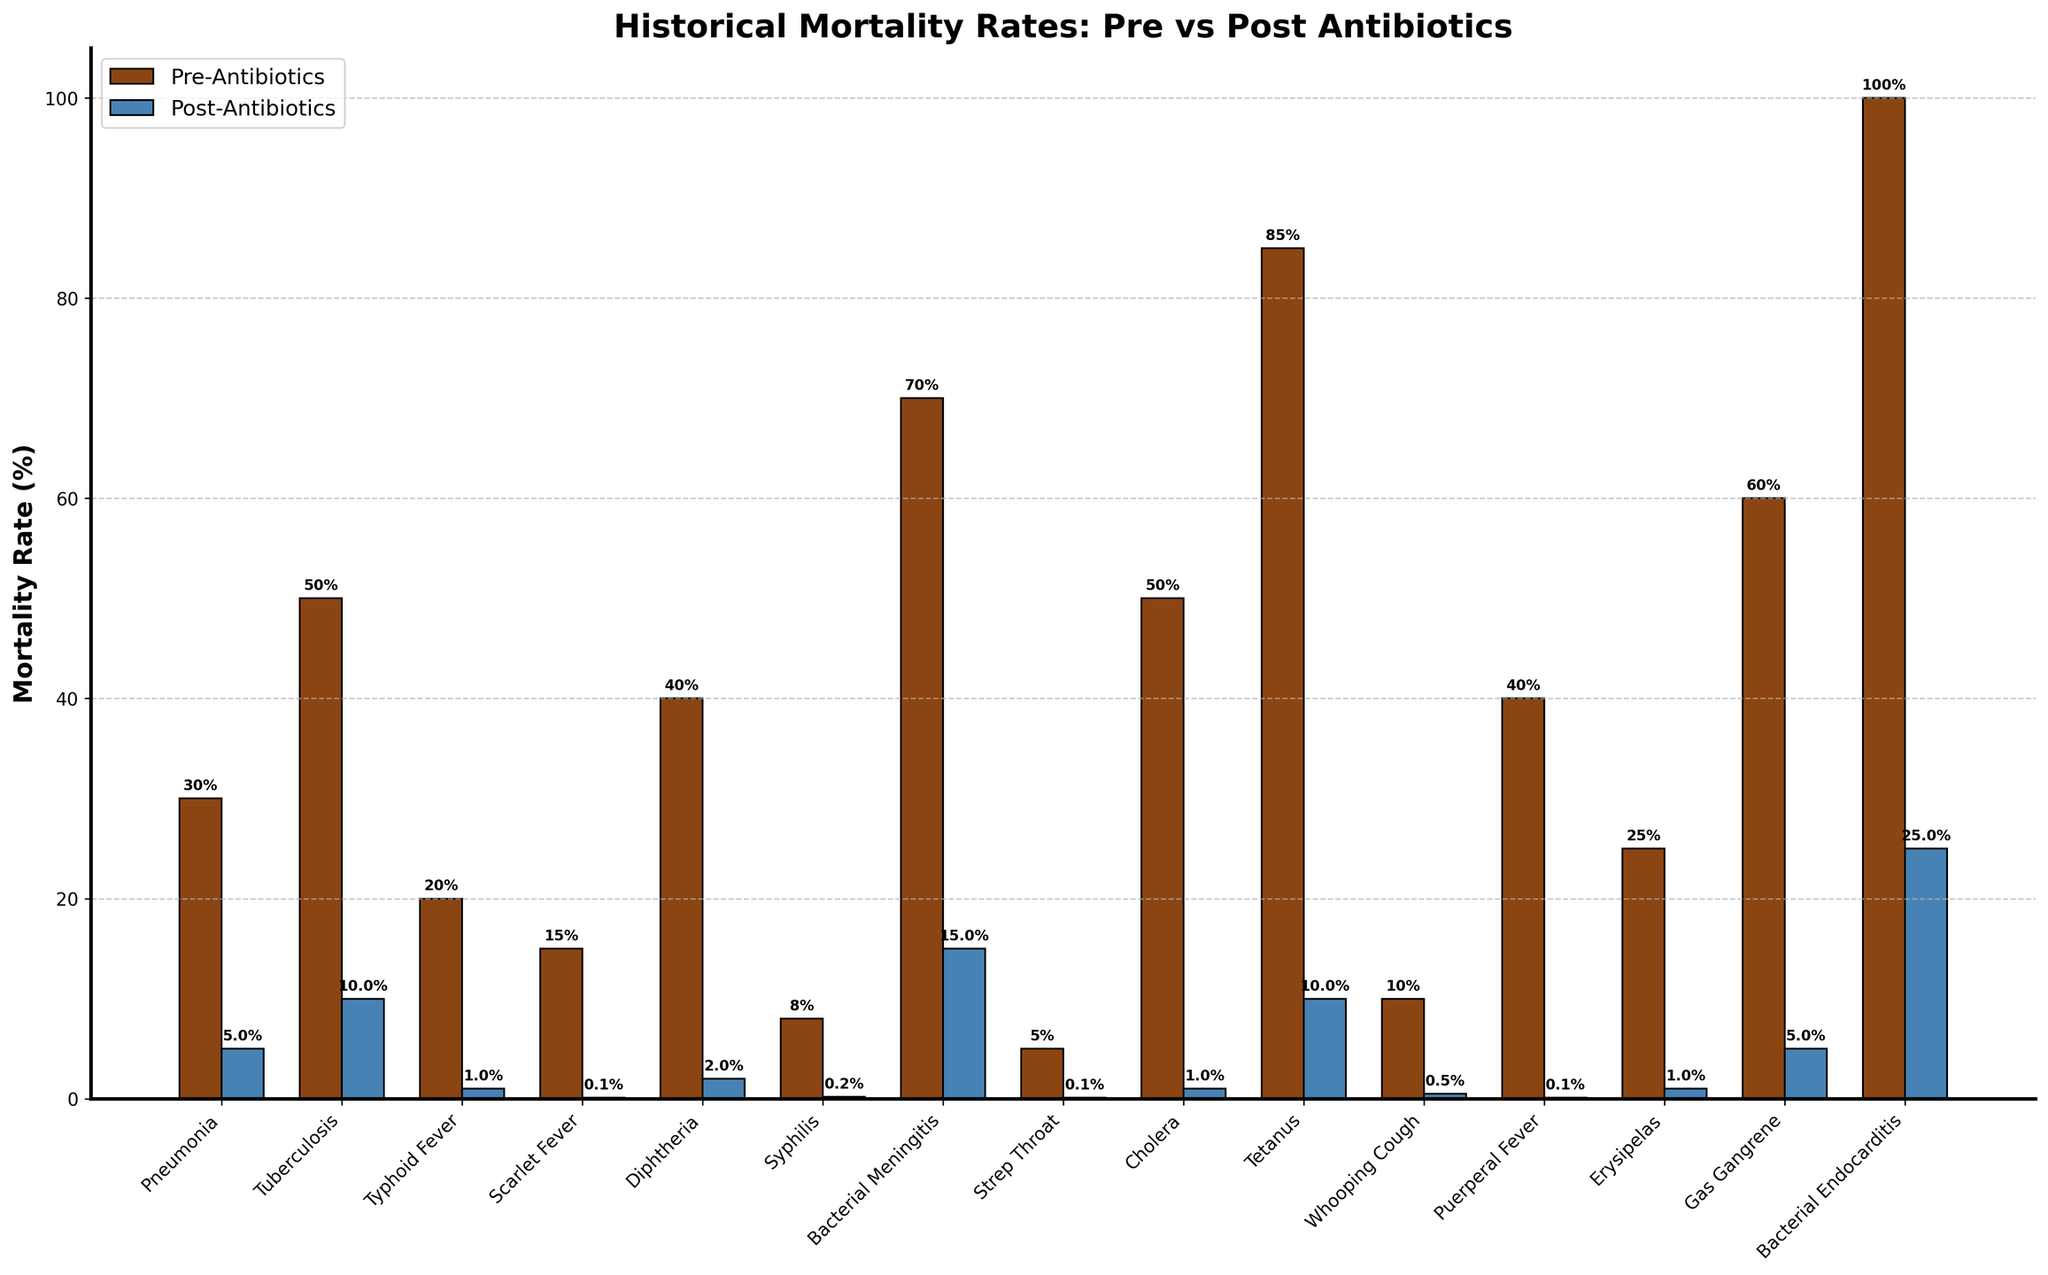Which disease shows the most significant drop in mortality rate post-antibiotics? To determine this, inspect the difference between the pre-antibiotics and post-antibiotics mortality rates for each disease. Bacterial Endocarditis decreases from 100% to 25%, a decrease of 75 percentage points.
Answer: Bacterial Endocarditis What is the difference in pre-antibiotics mortality rates between Tetanus and Diphtheria? Look at the bar heights for Tetanus and Diphtheria in the pre-antibiotics category. Tetanus is at 85%, and Diphtheria is at 40%. Subtract Diphtheria's rate from Tetanus's rate: 85% - 40% = 45%.
Answer: 45% Which disease had the lowest post-antibiotics mortality rate? Observe the post-antibiotics bar heights and identify the shortest one. Scarlet Fever, Strep Throat, and Puerperal Fever all have the lowest post-antibiotics mortality rate of 0.1%.
Answer: Scarlet Fever, Strep Throat, Puerperal Fever How much did the mortality rate of Gas Gangrene decrease after the advent of antibiotics? Check the pre-antibiotics and post-antibiotics bars for Gas Gangrene. Pre-antibiotics rate is 60%, and post-antibiotics rate is 5%. Subtract the post-antibiotics rate from the pre-antibiotics rate: 60% - 5% = 55%.
Answer: 55% Which disease had a higher pre-antibiotics mortality rate, Cholera or Tuberculosis? Compare the height of the pre-antibiotics bars for Cholera and Tuberculosis. Tuberculosis is at 50%, and Cholera is also at 50%, indicating they are equal.
Answer: Equal Which has a greater reduction in mortality rate, Pneumonia or Syphilis? Calculate the reduction for both diseases. Pneumonia drops from 30% to 5%, a decrease of 25 percentage points. Syphilis drops from 8% to 0.2%, a decrease of 7.8 percentage points. Pneumonia has a greater reduction.
Answer: Pneumonia Calculate the average post-antibiotics mortality rate of Tuberculosis, Cholera, and Bacterial Meningitis. Add the post-antibiotics rates of these diseases and divide by the number of diseases: (10% + 1% + 15%) / 3 = 26% / 3 ≈ 8.67%.
Answer: 8.67% Which disease had a pre-antibiotics mortality rate of exactly 20%? Look for the disease with a pre-antibiotics bar height of 20%. Typhoid Fever has a pre-antibiotics mortality rate of 20%.
Answer: Typhoid Fever 